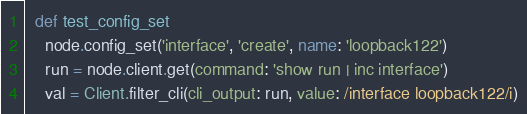Convert code to text. <code><loc_0><loc_0><loc_500><loc_500><_Ruby_>  def test_config_set
    node.config_set('interface', 'create', name: 'loopback122')
    run = node.client.get(command: 'show run | inc interface')
    val = Client.filter_cli(cli_output: run, value: /interface loopback122/i)</code> 